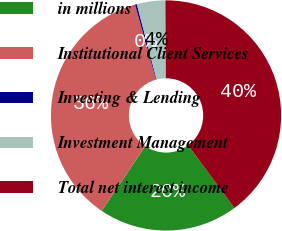Convert chart. <chart><loc_0><loc_0><loc_500><loc_500><pie_chart><fcel>in millions<fcel>Institutional Client Services<fcel>Investing & Lending<fcel>Investment Management<fcel>Total net interest income<nl><fcel>19.57%<fcel>36.21%<fcel>0.25%<fcel>4.0%<fcel>39.96%<nl></chart> 